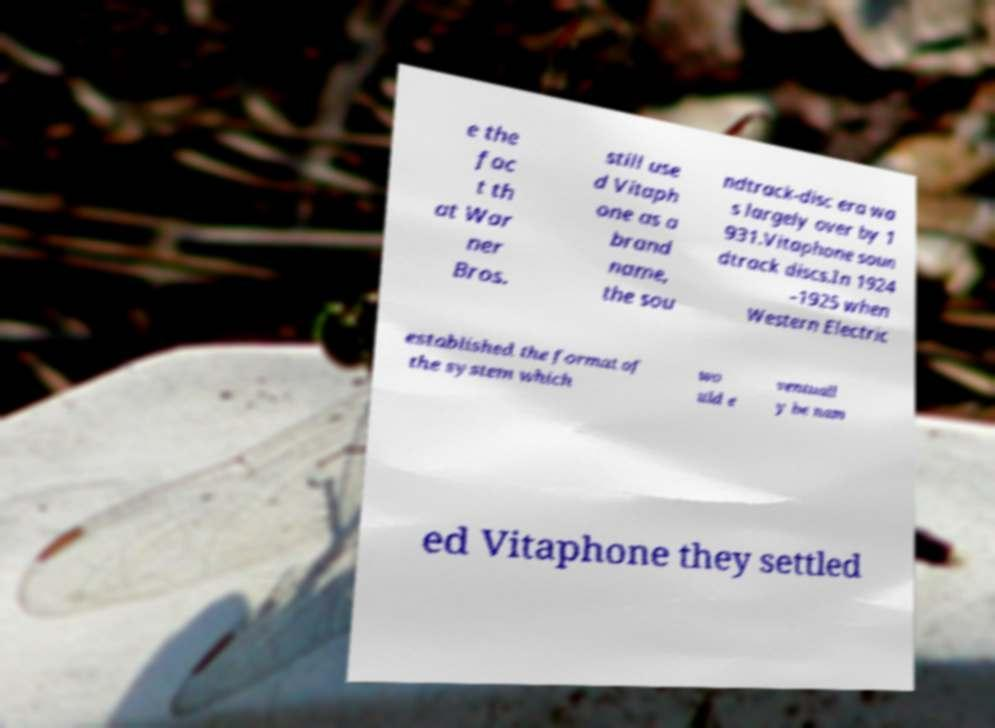What messages or text are displayed in this image? I need them in a readable, typed format. e the fac t th at War ner Bros. still use d Vitaph one as a brand name, the sou ndtrack-disc era wa s largely over by 1 931.Vitaphone soun dtrack discs.In 1924 –1925 when Western Electric established the format of the system which wo uld e ventuall y be nam ed Vitaphone they settled 